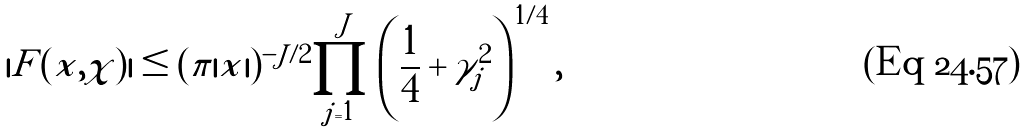<formula> <loc_0><loc_0><loc_500><loc_500>| F ( x , \chi ) | \leq ( \pi | x | ) ^ { - J / 2 } \prod _ { j = 1 } ^ { J } \left ( \frac { 1 } { 4 } + \gamma _ { j } ^ { 2 } \right ) ^ { 1 / 4 } ,</formula> 